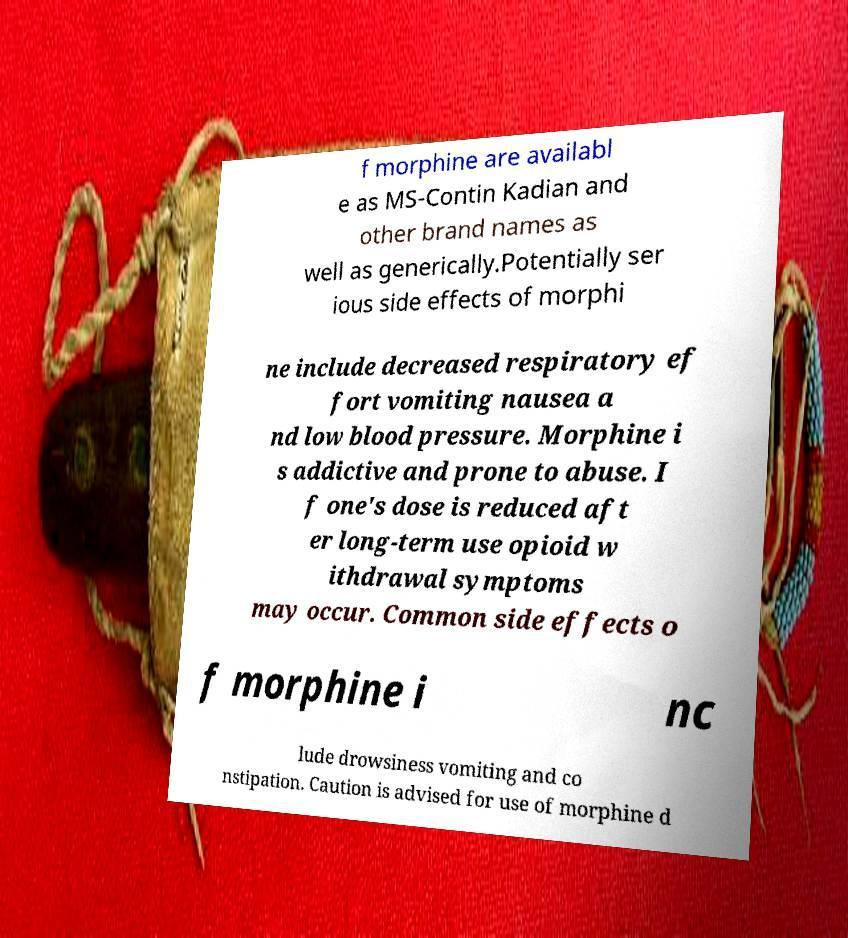For documentation purposes, I need the text within this image transcribed. Could you provide that? f morphine are availabl e as MS-Contin Kadian and other brand names as well as generically.Potentially ser ious side effects of morphi ne include decreased respiratory ef fort vomiting nausea a nd low blood pressure. Morphine i s addictive and prone to abuse. I f one's dose is reduced aft er long-term use opioid w ithdrawal symptoms may occur. Common side effects o f morphine i nc lude drowsiness vomiting and co nstipation. Caution is advised for use of morphine d 